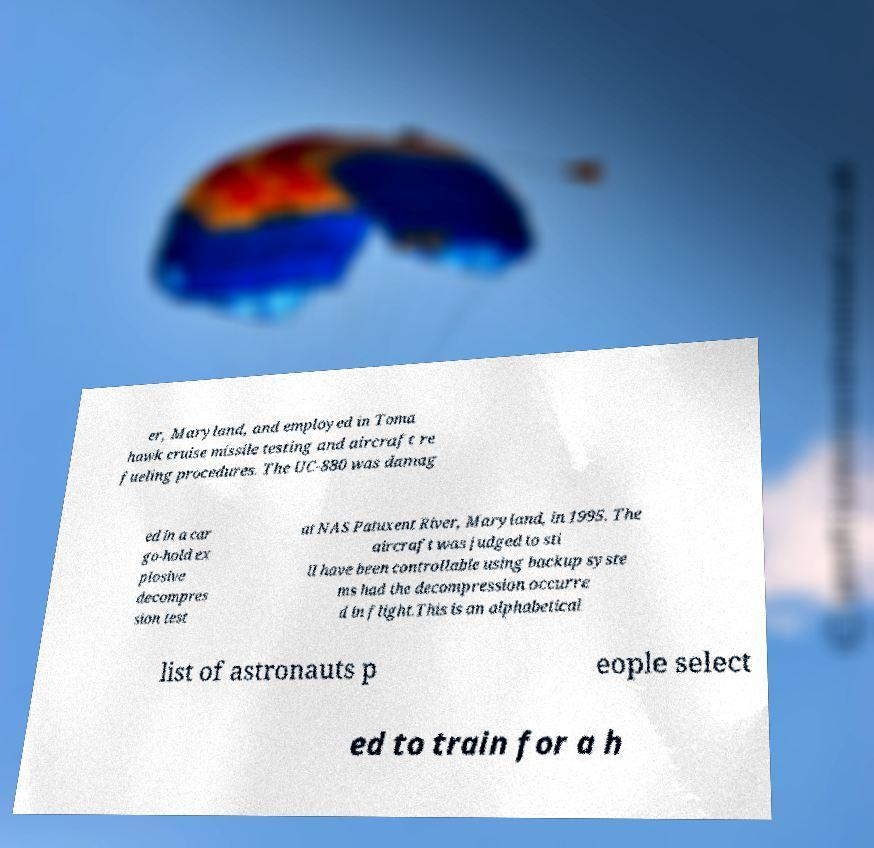For documentation purposes, I need the text within this image transcribed. Could you provide that? er, Maryland, and employed in Toma hawk cruise missile testing and aircraft re fueling procedures. The UC-880 was damag ed in a car go-hold ex plosive decompres sion test at NAS Patuxent River, Maryland, in 1995. The aircraft was judged to sti ll have been controllable using backup syste ms had the decompression occurre d in flight.This is an alphabetical list of astronauts p eople select ed to train for a h 